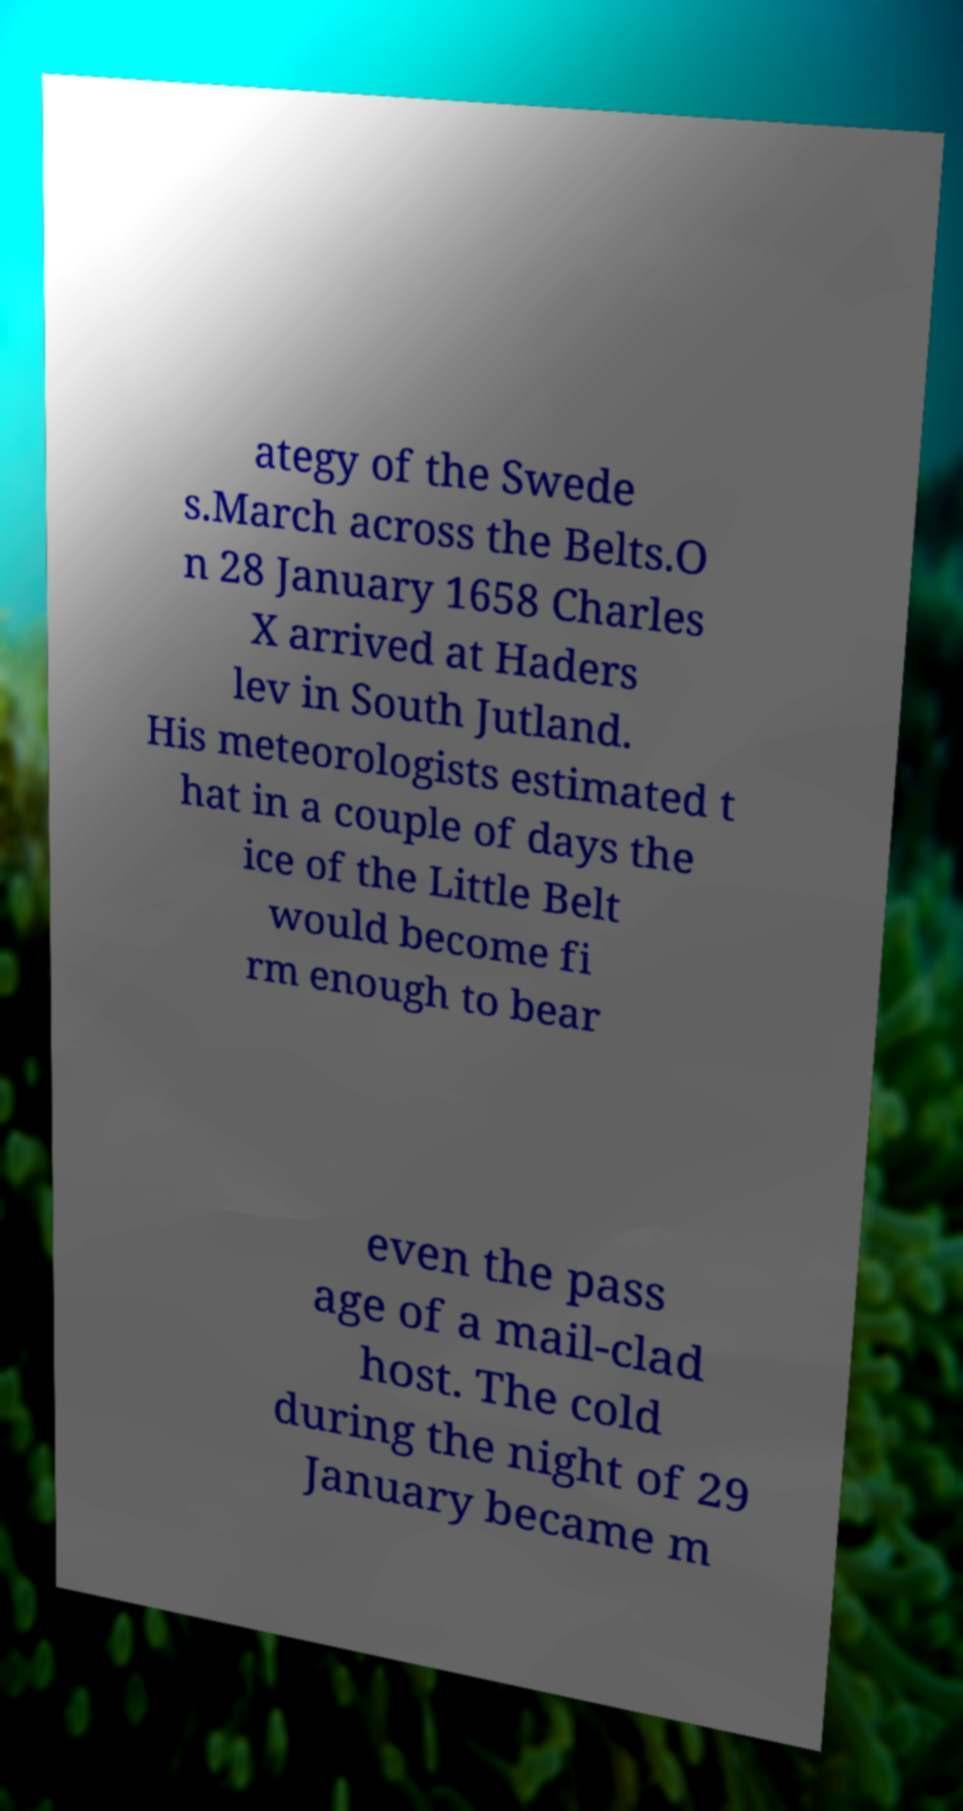Can you read and provide the text displayed in the image?This photo seems to have some interesting text. Can you extract and type it out for me? ategy of the Swede s.March across the Belts.O n 28 January 1658 Charles X arrived at Haders lev in South Jutland. His meteorologists estimated t hat in a couple of days the ice of the Little Belt would become fi rm enough to bear even the pass age of a mail-clad host. The cold during the night of 29 January became m 